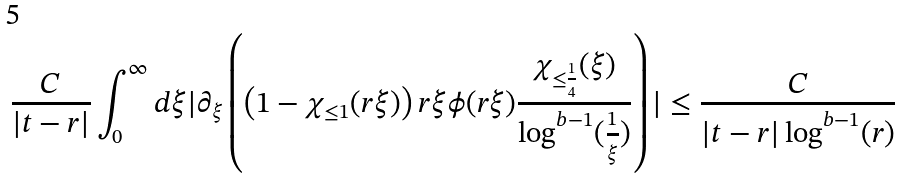Convert formula to latex. <formula><loc_0><loc_0><loc_500><loc_500>\frac { C } { | t - r | } \int _ { 0 } ^ { \infty } d \xi | \partial _ { \xi } \left ( \left ( 1 - \chi _ { \leq 1 } ( r \xi ) \right ) r \xi \phi ( r \xi ) \frac { \chi _ { \leq \frac { 1 } { 4 } } ( \xi ) } { \log ^ { b - 1 } ( \frac { 1 } { \xi } ) } \right ) | \leq \frac { C } { | t - r | \log ^ { b - 1 } ( r ) }</formula> 